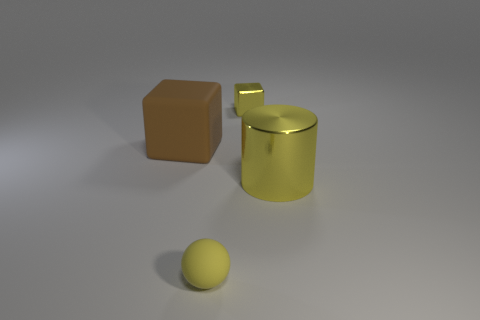What number of metallic things are large brown cylinders or large brown things?
Offer a terse response. 0. There is a metal object behind the large brown cube; does it have the same shape as the rubber object that is behind the tiny sphere?
Make the answer very short. Yes. What number of tiny things are behind the yellow sphere?
Your answer should be very brief. 1. Is there another small object made of the same material as the brown thing?
Offer a very short reply. Yes. What is the material of the brown block that is the same size as the yellow shiny cylinder?
Your answer should be very brief. Rubber. Are the large block and the big cylinder made of the same material?
Ensure brevity in your answer.  No. What number of objects are small cyan metallic cubes or small matte balls?
Your response must be concise. 1. What shape is the small thing that is behind the brown object?
Your answer should be very brief. Cube. What is the color of the small thing that is the same material as the yellow cylinder?
Provide a succinct answer. Yellow. There is a small thing that is the same shape as the big rubber object; what is its material?
Your answer should be compact. Metal. 